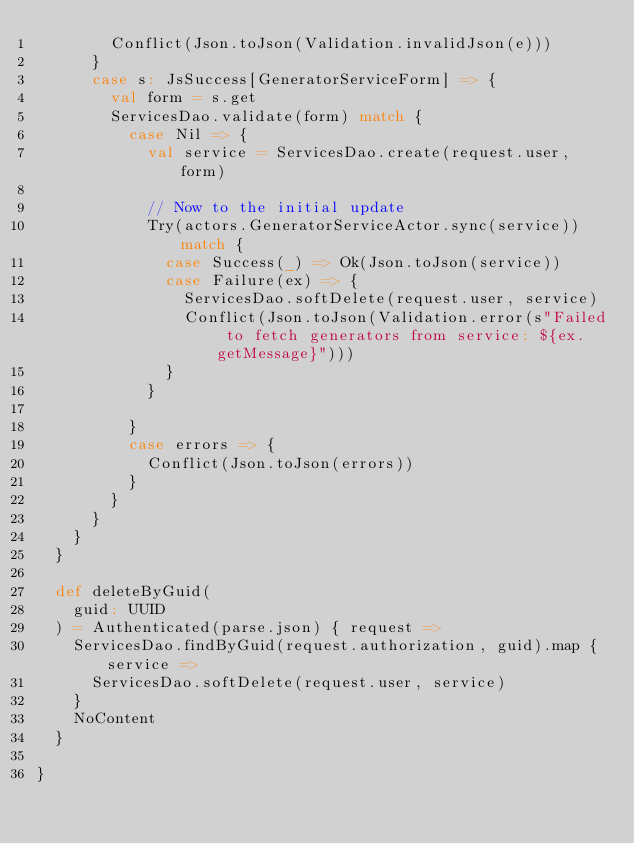Convert code to text. <code><loc_0><loc_0><loc_500><loc_500><_Scala_>        Conflict(Json.toJson(Validation.invalidJson(e)))
      }
      case s: JsSuccess[GeneratorServiceForm] => {
        val form = s.get
        ServicesDao.validate(form) match {
          case Nil => {
            val service = ServicesDao.create(request.user, form)

            // Now to the initial update
            Try(actors.GeneratorServiceActor.sync(service)) match {
              case Success(_) => Ok(Json.toJson(service))
              case Failure(ex) => {
                ServicesDao.softDelete(request.user, service)
                Conflict(Json.toJson(Validation.error(s"Failed to fetch generators from service: ${ex.getMessage}")))
              }
            }
            
          }
          case errors => {
            Conflict(Json.toJson(errors))
          }
        }
      }
    }
  }

  def deleteByGuid(
    guid: UUID
  ) = Authenticated(parse.json) { request =>
    ServicesDao.findByGuid(request.authorization, guid).map { service =>
      ServicesDao.softDelete(request.user, service)
    }
    NoContent
  }

}

</code> 